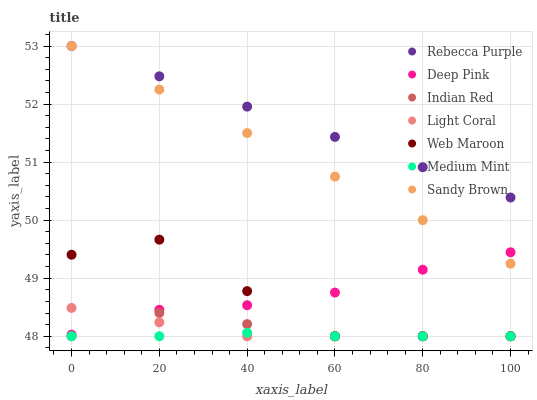Does Medium Mint have the minimum area under the curve?
Answer yes or no. Yes. Does Rebecca Purple have the maximum area under the curve?
Answer yes or no. Yes. Does Deep Pink have the minimum area under the curve?
Answer yes or no. No. Does Deep Pink have the maximum area under the curve?
Answer yes or no. No. Is Sandy Brown the smoothest?
Answer yes or no. Yes. Is Web Maroon the roughest?
Answer yes or no. Yes. Is Deep Pink the smoothest?
Answer yes or no. No. Is Deep Pink the roughest?
Answer yes or no. No. Does Medium Mint have the lowest value?
Answer yes or no. Yes. Does Deep Pink have the lowest value?
Answer yes or no. No. Does Sandy Brown have the highest value?
Answer yes or no. Yes. Does Deep Pink have the highest value?
Answer yes or no. No. Is Web Maroon less than Sandy Brown?
Answer yes or no. Yes. Is Deep Pink greater than Medium Mint?
Answer yes or no. Yes. Does Light Coral intersect Indian Red?
Answer yes or no. Yes. Is Light Coral less than Indian Red?
Answer yes or no. No. Is Light Coral greater than Indian Red?
Answer yes or no. No. Does Web Maroon intersect Sandy Brown?
Answer yes or no. No. 